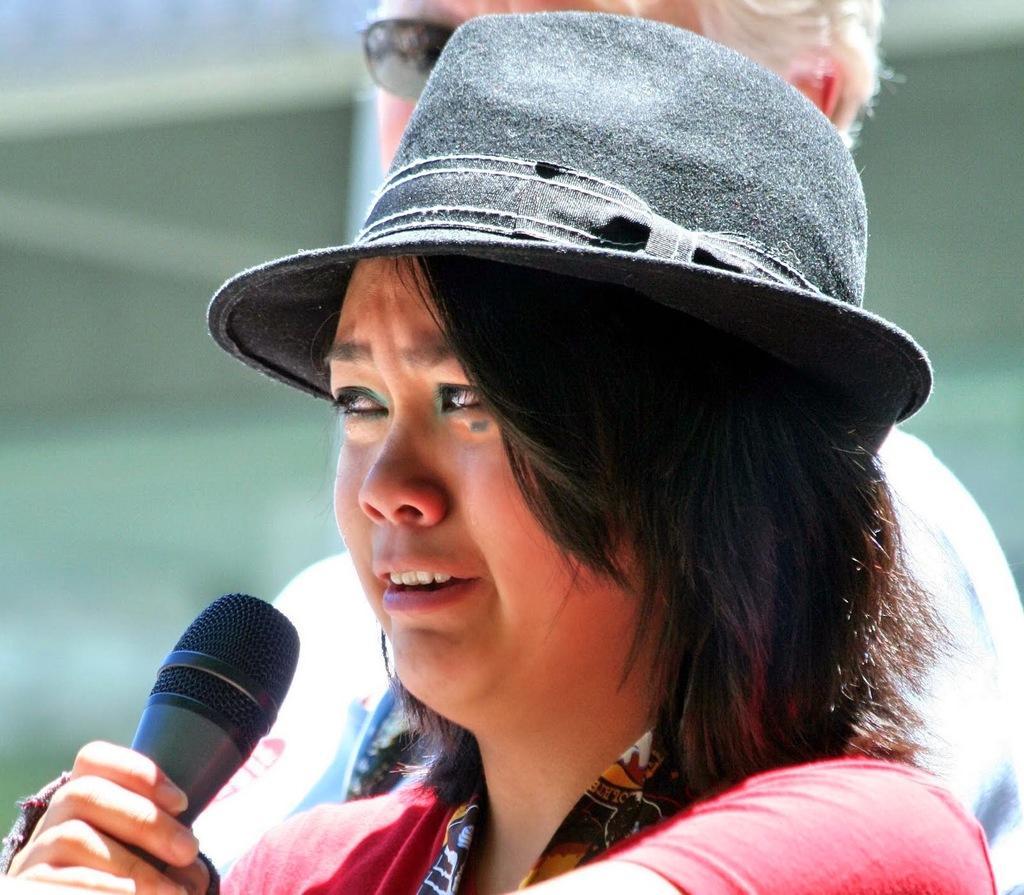How would you summarize this image in a sentence or two? This is a picture of a woman in a hat holding a microphone. Background of this woman is another person. 